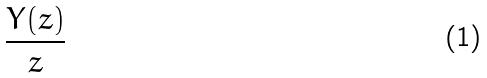<formula> <loc_0><loc_0><loc_500><loc_500>\frac { Y ( z ) } { z }</formula> 